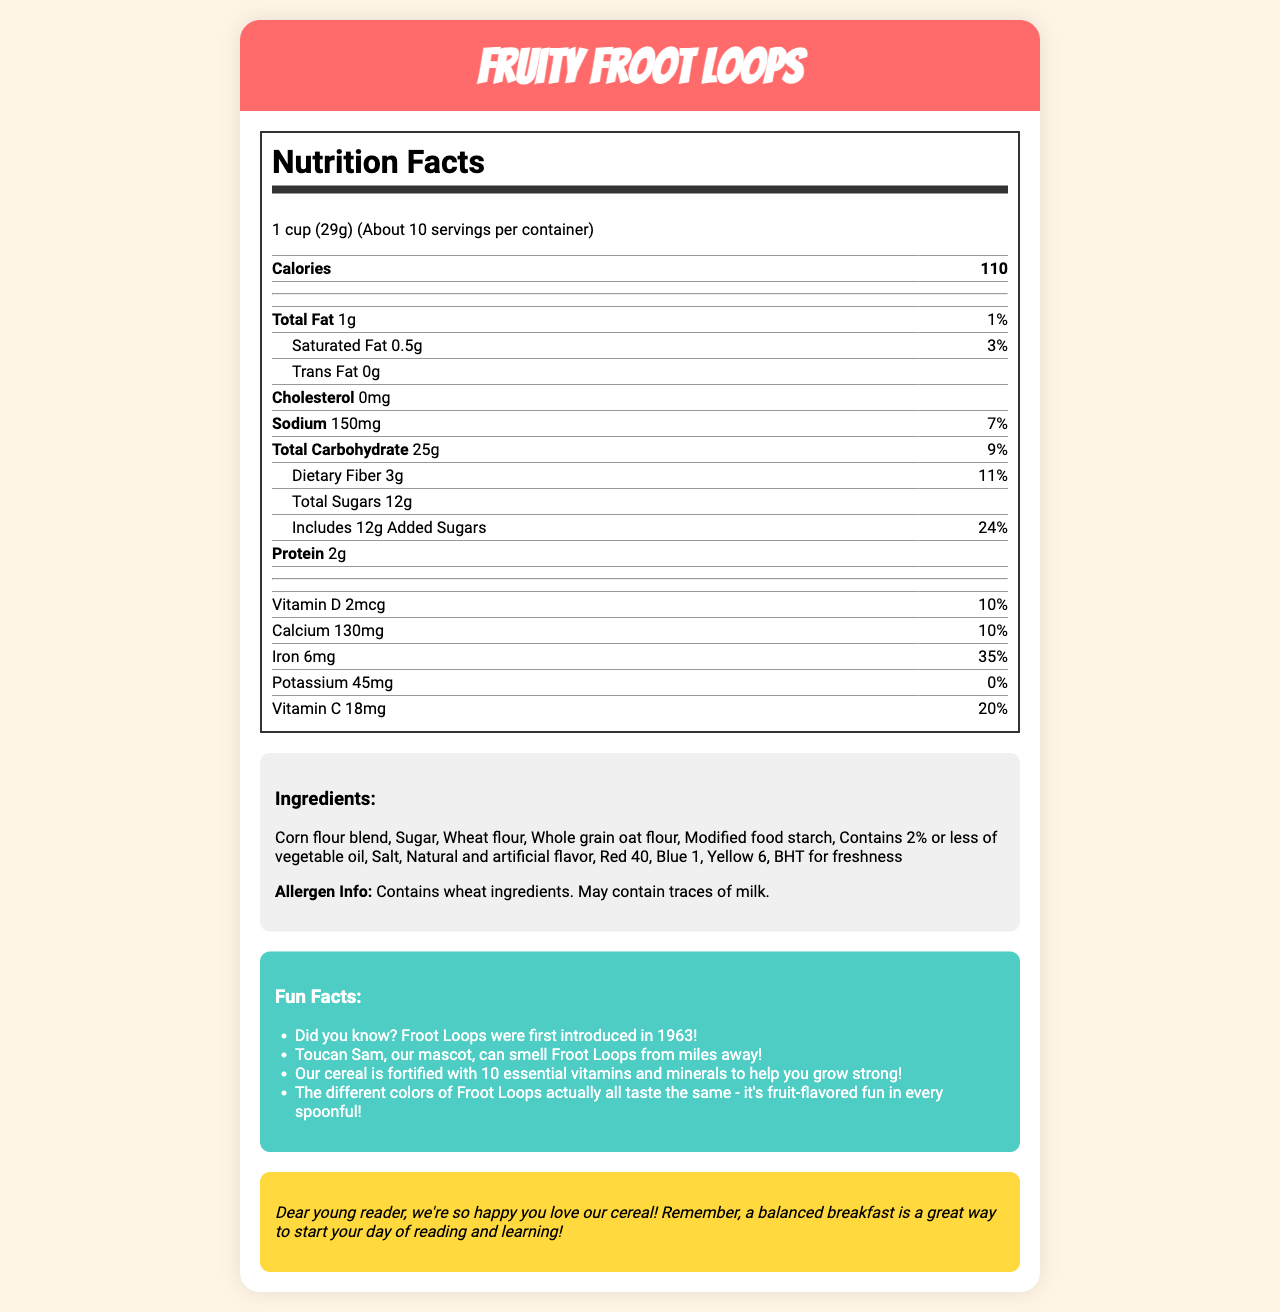who is the mascot of Fruity Froot Loops? The fun facts section mentions, "Toucan Sam, our mascot, can smell Froot Loops from miles away!"
Answer: Toucan Sam how many servings are there per container? The serving size section lists "About 10 servings per container."
Answer: About 10 what is the total carbohydrate content per serving? In the nutrition label, it states, "Total Carbohydrate 25g."
Answer: 25g how much vitamin C does one serving provide? The nutrition label indicates "Vitamin C 18mg."
Answer: 18mg what is the allergen information for this cereal? The ingredients section provides this allergen information.
Answer: Contains wheat ingredients. May contain traces of milk. which of the following ingredients is not included in Fruity Froot Loops? A. Corn flour blend B. Sugar C. Almond flour D. Whole grain oat flour The ingredients section lists several items, but almond flour is not mentioned.
Answer: C. Almond flour how many grams of dietary fiber are in one serving? A. 3g B. 5g C. 8g D. 10g The nutrition label specifies "Dietary Fiber 3g."
Answer: A. 3g is the document educational or entertaining? The document provides nutritional information (educational) and fun facts with colorful graphics (entertaining).
Answer: Both does the product contain any cholesterol? The nutrition label lists "Cholesterol 0mg."
Answer: No summarize the main content of the document. The document combines nutritional data, ingredients, fun facts, colorful graphics, and a special message to create an informative and engaging overview of Fruity Froot Loops cereal.
Answer: The document provides detailed nutritional information and ingredients for Fruity Froot Loops cereal. It includes a nutrition facts label, allergen information, fun facts about the cereal, and a special message to young readers. what is the origin story of Toucan Sam? The document does not provide information about the origin story of Toucan Sam. Only a fun fact mentions him.
Answer: Cannot be determined what percentage of daily value is the added sugars? The nutrition label indicates "Includes 12g Added Sugars," which is 24% of the daily value.
Answer: 24% how many calories are there per serving? The nutrition label lists "Calories 110."
Answer: 110 what essential vitamins and minerals are mentioned in the document? These are listed in the nutrition label under their respective amounts and daily values.
Answer: Vitamin D, Calcium, Iron, Potassium, Vitamin C how much sodium does one serving contain? According to the nutrition label, "Sodium 150mg."
Answer: 150mg what visual elements are used in the document? These colorful graphics are mentioned at the beginning of the document as part of the visual presentation.
Answer: A smiling Toucan Sam giving a thumbs up, a rainbow made of Froot Loops, an animated milk splash, fruit-shaped Froot Loops characters dancing 